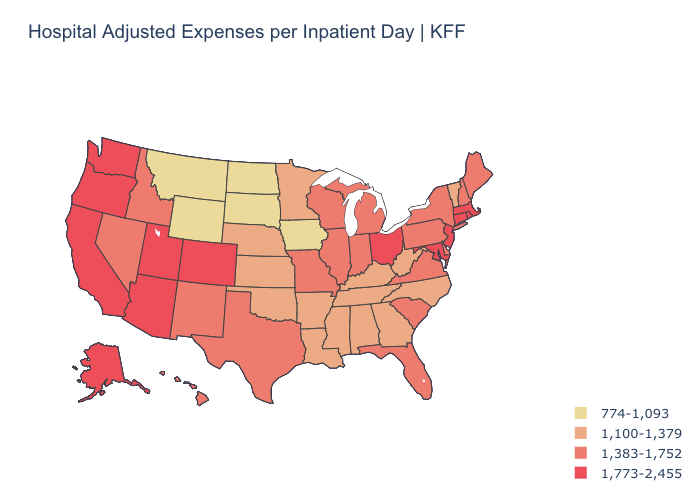Does Michigan have the same value as Colorado?
Give a very brief answer. No. Does the map have missing data?
Answer briefly. No. Name the states that have a value in the range 1,383-1,752?
Short answer required. Delaware, Florida, Hawaii, Idaho, Illinois, Indiana, Maine, Michigan, Missouri, Nevada, New Hampshire, New Mexico, New York, Pennsylvania, South Carolina, Texas, Virginia, Wisconsin. What is the highest value in states that border Virginia?
Give a very brief answer. 1,773-2,455. Does Kansas have the lowest value in the MidWest?
Keep it brief. No. Name the states that have a value in the range 1,383-1,752?
Concise answer only. Delaware, Florida, Hawaii, Idaho, Illinois, Indiana, Maine, Michigan, Missouri, Nevada, New Hampshire, New Mexico, New York, Pennsylvania, South Carolina, Texas, Virginia, Wisconsin. Which states hav the highest value in the MidWest?
Answer briefly. Ohio. Does Montana have the lowest value in the USA?
Short answer required. Yes. Name the states that have a value in the range 774-1,093?
Keep it brief. Iowa, Montana, North Dakota, South Dakota, Wyoming. What is the highest value in states that border Vermont?
Give a very brief answer. 1,773-2,455. Which states hav the highest value in the MidWest?
Concise answer only. Ohio. What is the value of Arkansas?
Give a very brief answer. 1,100-1,379. Name the states that have a value in the range 1,773-2,455?
Concise answer only. Alaska, Arizona, California, Colorado, Connecticut, Maryland, Massachusetts, New Jersey, Ohio, Oregon, Rhode Island, Utah, Washington. Name the states that have a value in the range 774-1,093?
Answer briefly. Iowa, Montana, North Dakota, South Dakota, Wyoming. Which states have the lowest value in the West?
Quick response, please. Montana, Wyoming. 